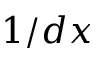<formula> <loc_0><loc_0><loc_500><loc_500>1 / d x</formula> 